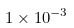<formula> <loc_0><loc_0><loc_500><loc_500>1 \times 1 0 ^ { - 3 }</formula> 